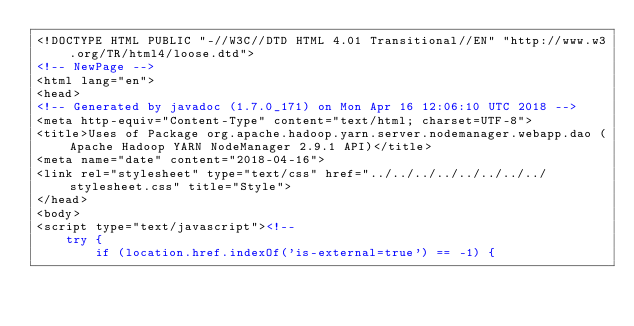Convert code to text. <code><loc_0><loc_0><loc_500><loc_500><_HTML_><!DOCTYPE HTML PUBLIC "-//W3C//DTD HTML 4.01 Transitional//EN" "http://www.w3.org/TR/html4/loose.dtd">
<!-- NewPage -->
<html lang="en">
<head>
<!-- Generated by javadoc (1.7.0_171) on Mon Apr 16 12:06:10 UTC 2018 -->
<meta http-equiv="Content-Type" content="text/html; charset=UTF-8">
<title>Uses of Package org.apache.hadoop.yarn.server.nodemanager.webapp.dao (Apache Hadoop YARN NodeManager 2.9.1 API)</title>
<meta name="date" content="2018-04-16">
<link rel="stylesheet" type="text/css" href="../../../../../../../../stylesheet.css" title="Style">
</head>
<body>
<script type="text/javascript"><!--
    try {
        if (location.href.indexOf('is-external=true') == -1) {</code> 